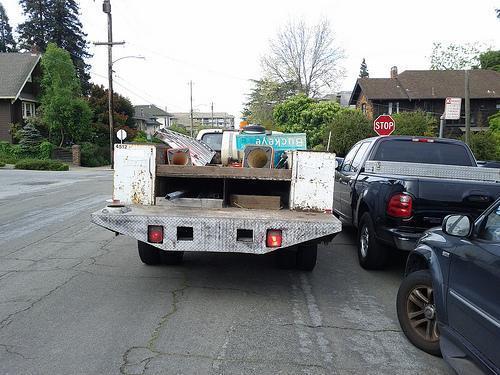How many vehicles are visible in this photo?
Give a very brief answer. 4. How many lights are lit on the back of the white truck in the picture?
Give a very brief answer. 2. 